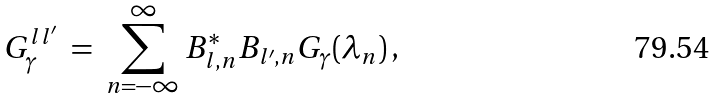Convert formula to latex. <formula><loc_0><loc_0><loc_500><loc_500>G _ { \gamma } ^ { l l ^ { \prime } } \ = \ \sum ^ { \infty } _ { n = - \infty } B ^ { \ast } _ { l , n } B _ { l ^ { \prime } , n } G _ { \gamma } ( \lambda _ { n } ) \, ,</formula> 